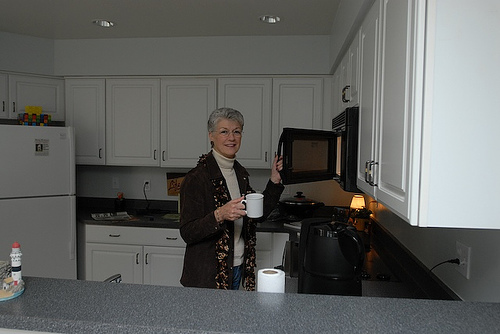<image>What brand is the refrigerator? I don't know what brand the refrigerator is. It can be whirlpool, ge, samsung, lg, or kenmore. What is the name of the gaming system on the TV stand? There is no gaming system on the TV stand in the image. What is the man in the lift doing? I don't know what the man in the lift is doing. There might be no man in the lift. What brand is the refrigerator? I am not sure what brand the refrigerator is. It can be whirlpool, ge, lg, samsung, kenmore or I don't know. What is the name of the gaming system on the TV stand? The name of the gaming system on the TV stand is not pictured. What is the man in the lift doing? I am not sure what the man in the lift is doing. It can be seen that he is opening the microwave. 